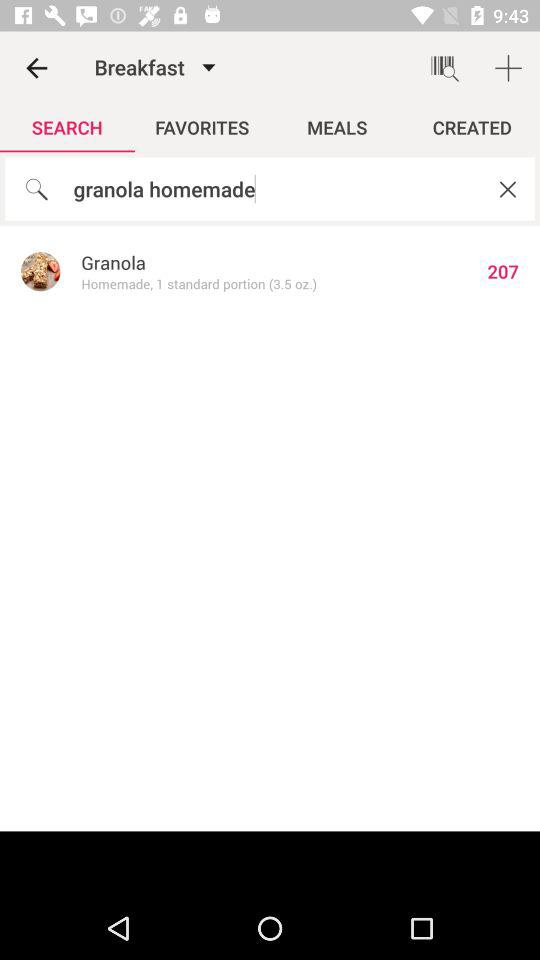How many grams of granola are in the standard portion?
Answer the question using a single word or phrase. 3.5 